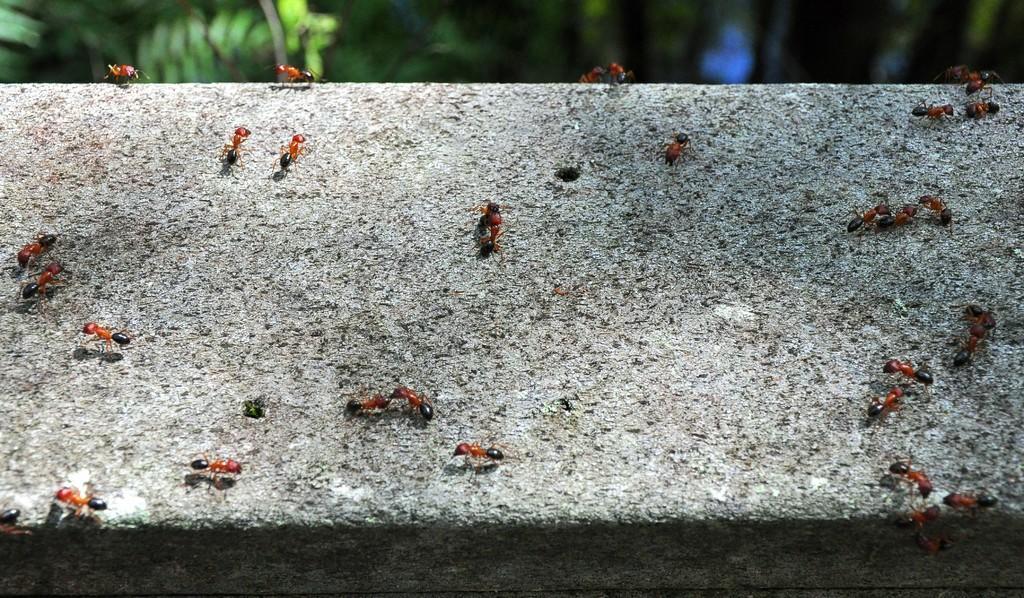Can you describe this image briefly? In this picture we can see ants on a stone and in the background we can see trees. 